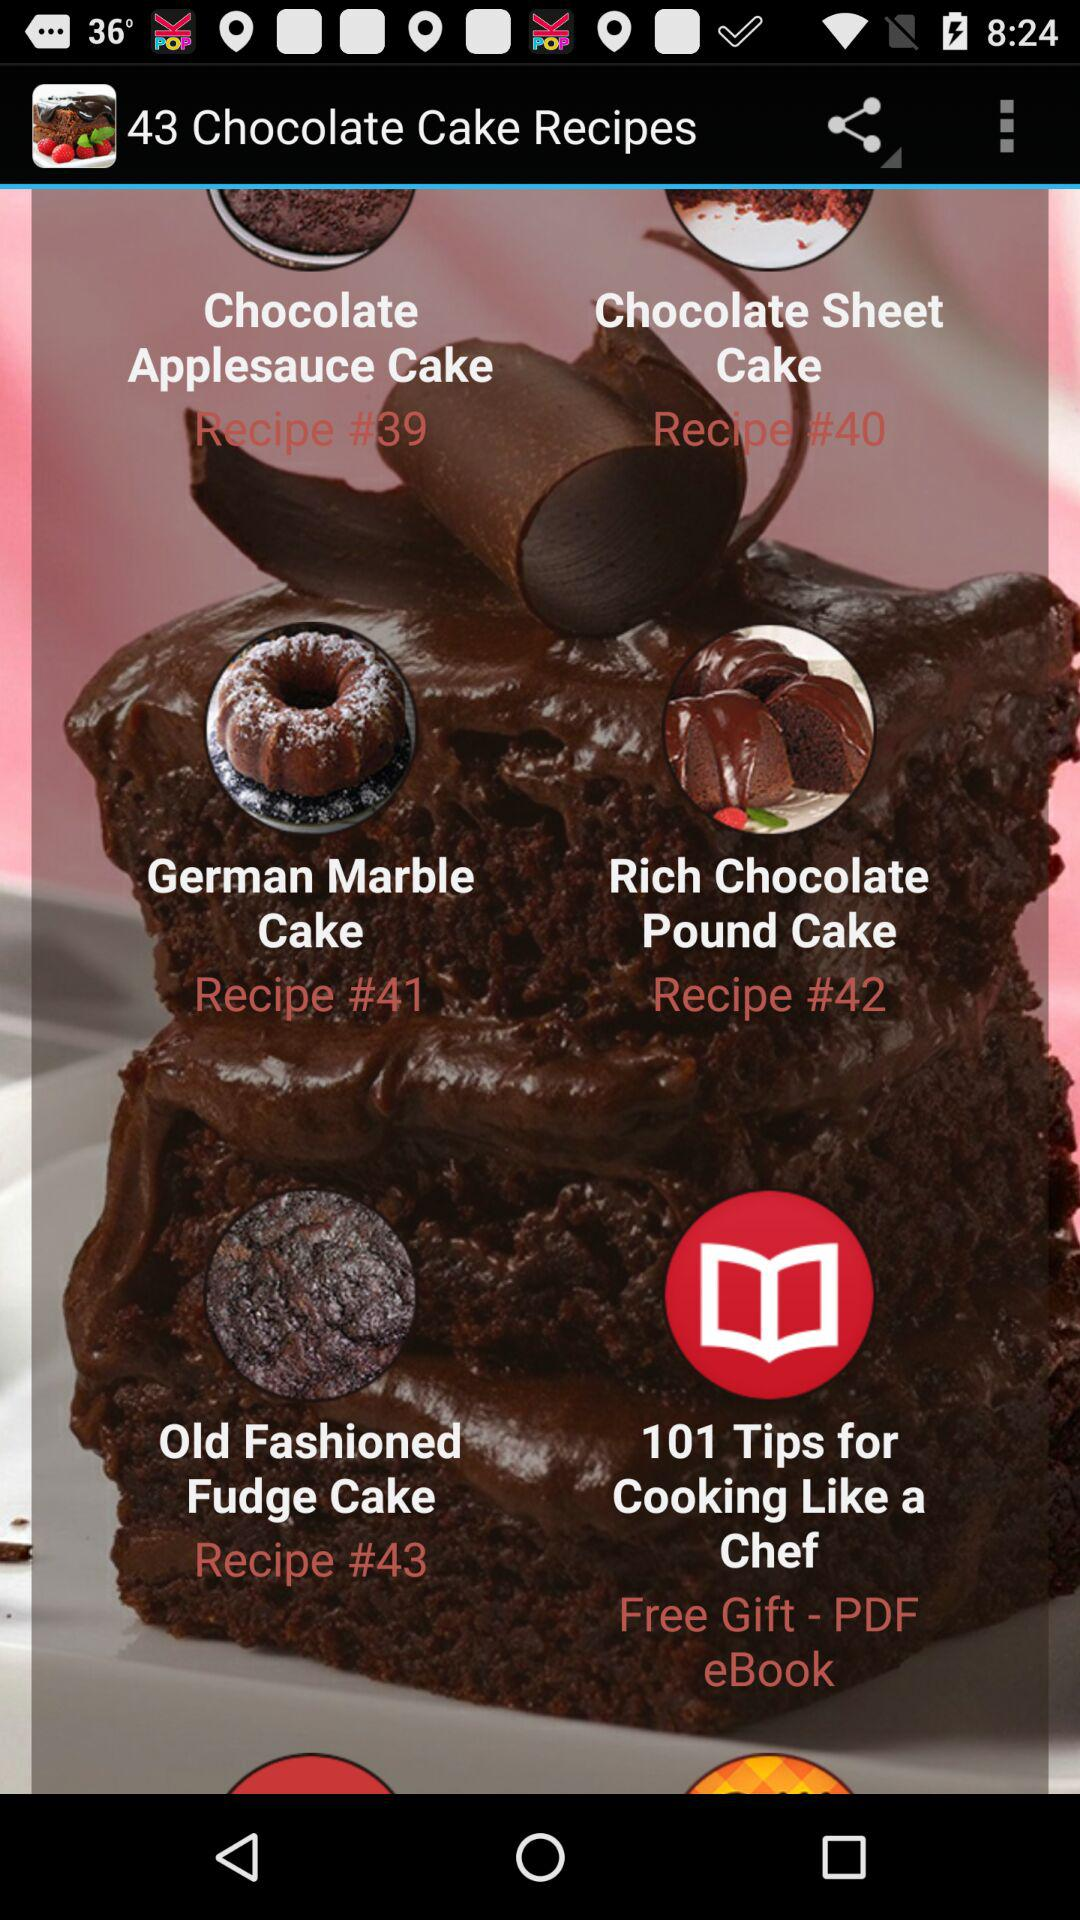What is recipe number 39? Recipe number 39 is Chocolate Applesauce Cake. 